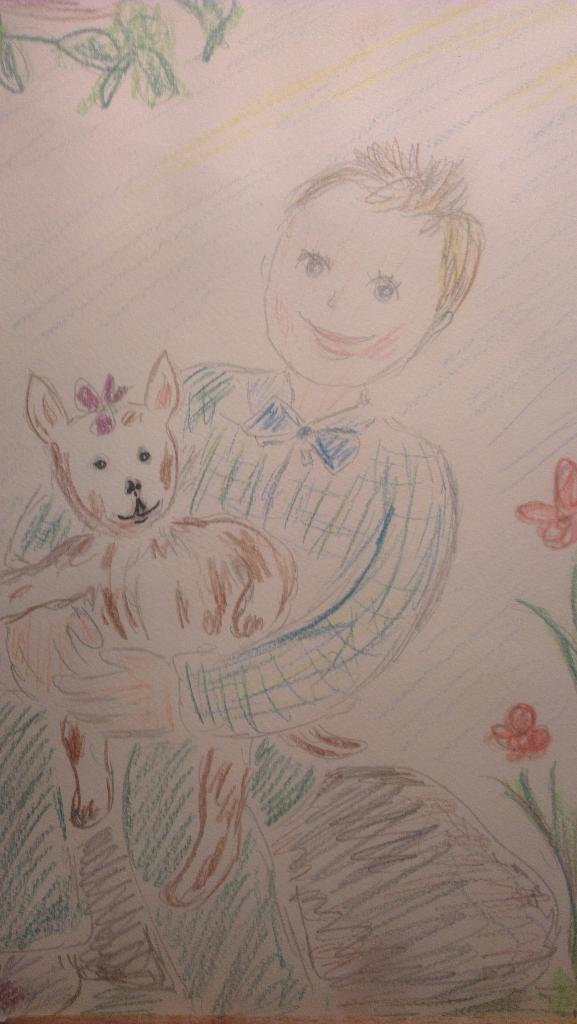What is depicted in the sketch in the image? The sketch contains a child and a dog. What colors are used in the sketch? The sketch includes blue, brown, pink, and red colors. Where are the flowers located in the image? The flowers are on the right side of the image. What type of suit is the toad wearing in the image? There is no toad or suit present in the image; it contains a sketch of a child and a dog with flowers on the right side. 